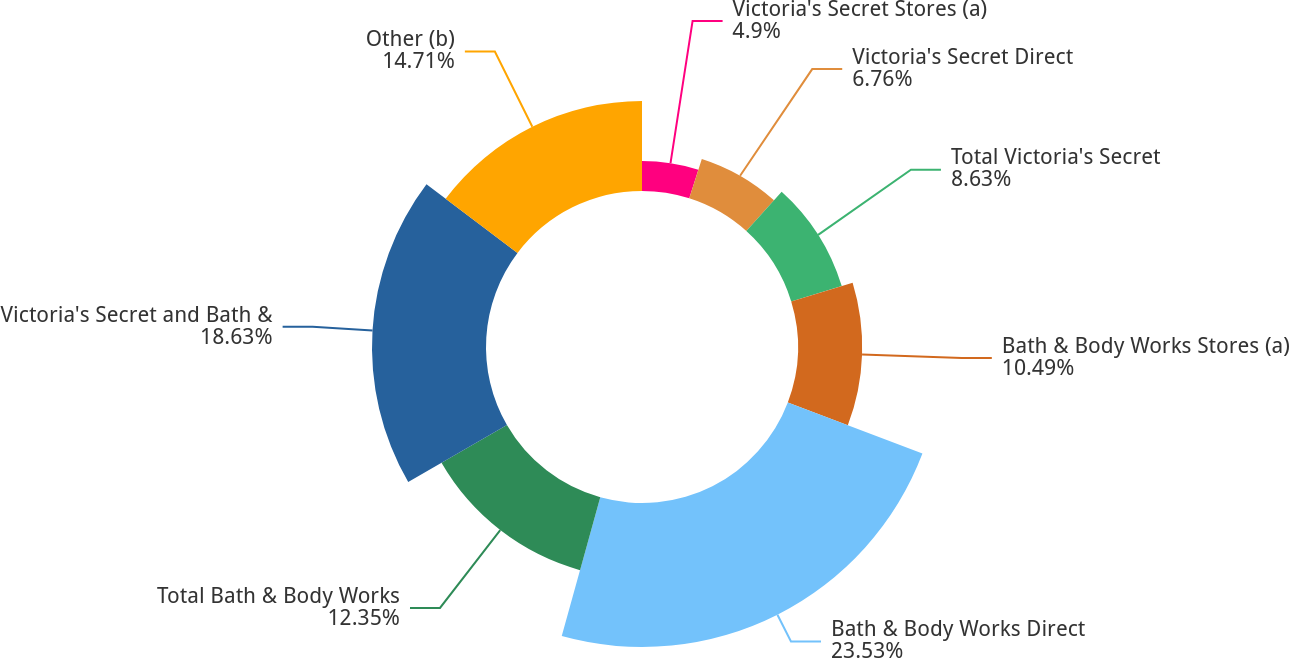Convert chart. <chart><loc_0><loc_0><loc_500><loc_500><pie_chart><fcel>Victoria's Secret Stores (a)<fcel>Victoria's Secret Direct<fcel>Total Victoria's Secret<fcel>Bath & Body Works Stores (a)<fcel>Bath & Body Works Direct<fcel>Total Bath & Body Works<fcel>Victoria's Secret and Bath &<fcel>Other (b)<nl><fcel>4.9%<fcel>6.76%<fcel>8.63%<fcel>10.49%<fcel>23.53%<fcel>12.35%<fcel>18.63%<fcel>14.71%<nl></chart> 